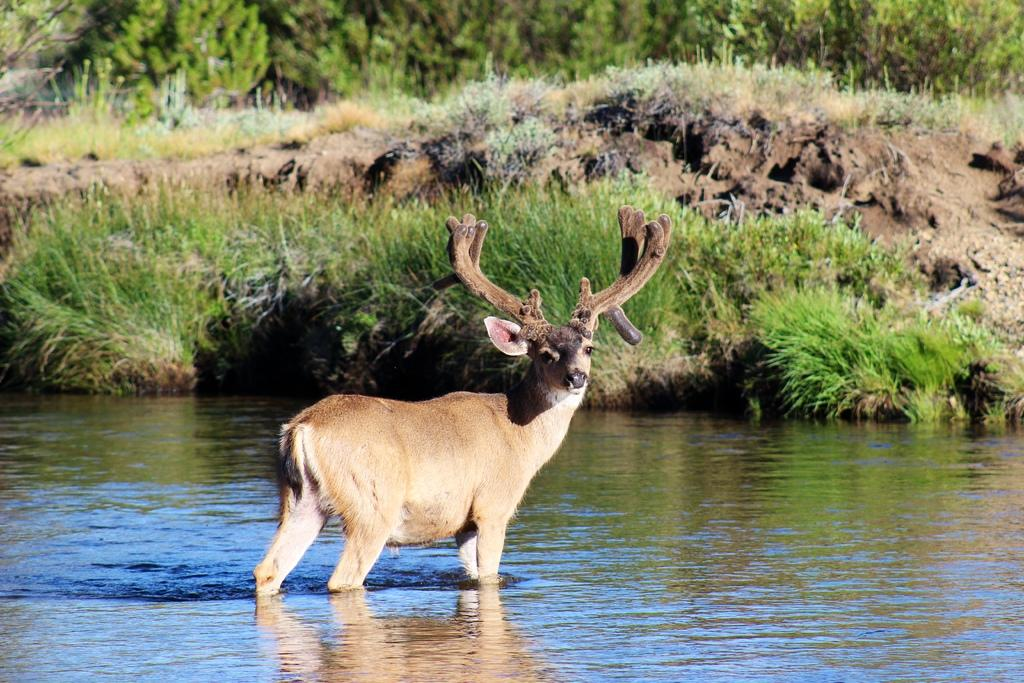What animal can be seen in the image? There is a deer in the image. Where is the deer located in the image? The deer is standing in the water. What type of vegetation is visible in the image? Grass is visible in the image. What other natural elements can be seen in the image? Trees are present in the image. What type of leather is being used to create a power source in the image? There is no leather or power source present in the image; it features a deer standing in the water with grass and trees in the background. 